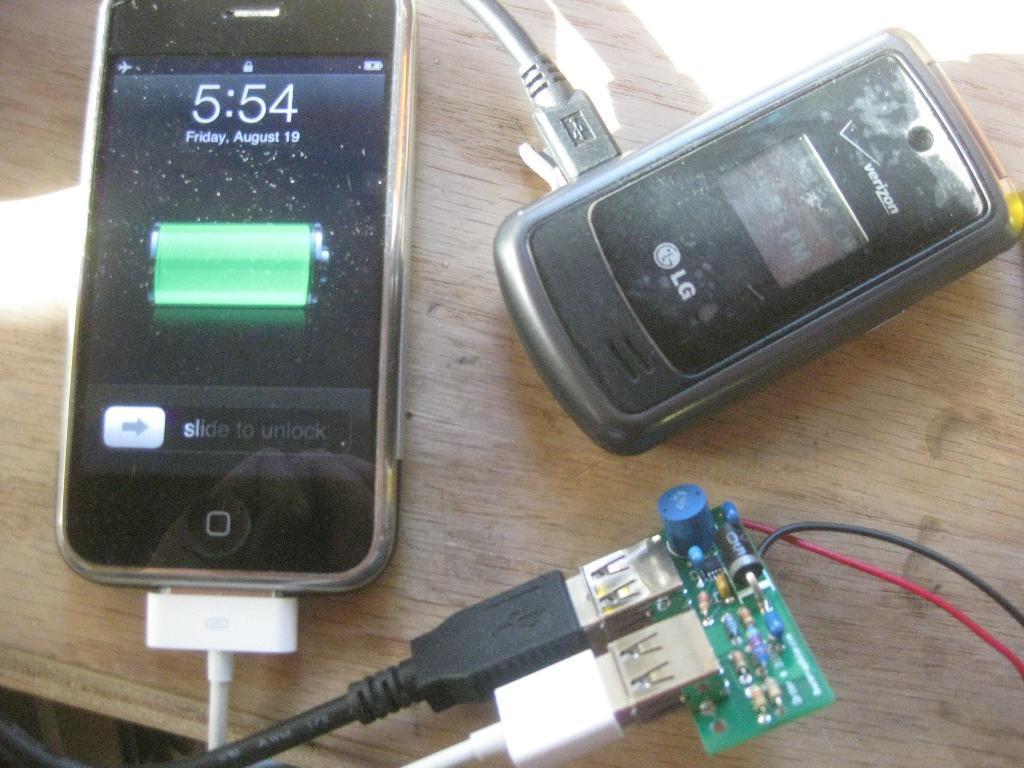Can you describe this image briefly? In the image there is a table on that there are two mobiles. On the left there is a mobile which is attached to a USB cable. I think it is charging. 